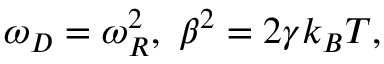<formula> <loc_0><loc_0><loc_500><loc_500>\omega _ { D } = \omega _ { R } ^ { 2 } , \ \beta ^ { 2 } = 2 \gamma k _ { B } T ,</formula> 